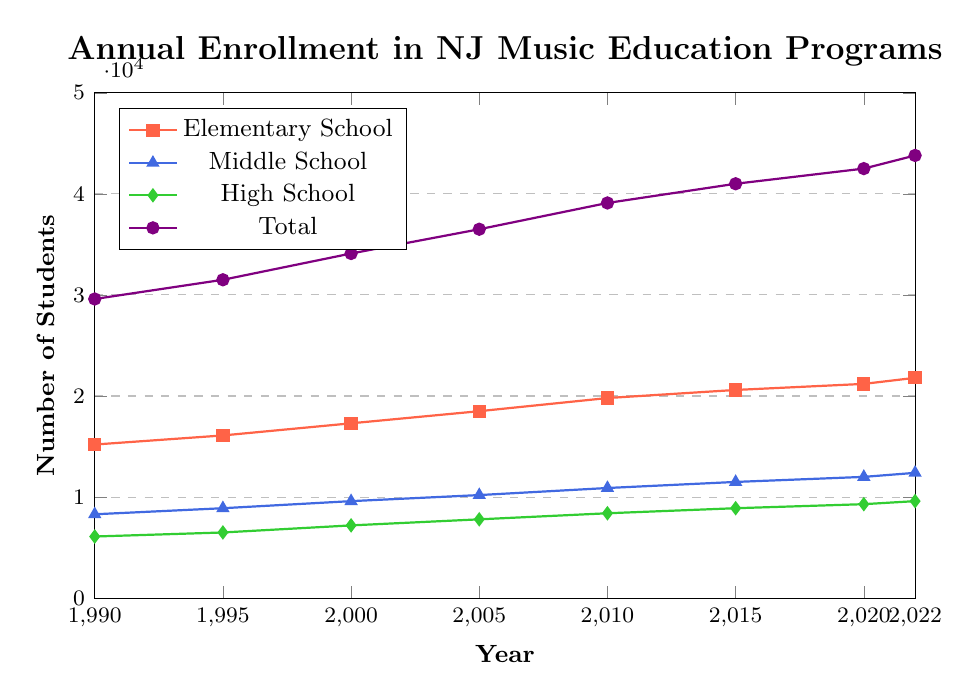What's the total enrollment for music education programs in 2005? Look for the data point in the "Total" series for the year 2005, which shows the total number of students enrolled in that year.
Answer: 36500 How many more students were enrolled in elementary school music programs in 2022 compared to 1990? Subtract the number of students enrolled in elementary schools in 1990 from the number enrolled in 2022 (21800 - 15200).
Answer: 6600 Which school level had the highest increase in student enrollment from 1990 to 2022? Calculate the difference in student enrollment for each school level between 1990 and 2022. Elementary: 21800 - 15200 = 6600, Middle: 12400 - 8300 = 4100, High: 9600 - 6100 = 3500. Identify the highest difference.
Answer: Elementary School What is the average annual enrollment in middle school music programs from 1990 to 2022? Sum the middle school enrollments across all years and divide by the number of data points (8300 + 8900 + 9600 + 10200 + 10900 + 11500 + 12000 + 12400) / 8.
Answer: 10350 By how much did the total number of students enrolled in music programs increase from 2000 to 2020? Subtract the total enrollment in 2000 from the total enrollment in 2020 (42500 - 34100).
Answer: 8400 In which year did high school music enrollment first exceed 9000 students? Identify the first year in the "High School" series where the enrollment exceeds 9000. 2015: 8900, 2020: 9300.
Answer: 2020 Which school level had the least change in enrollment from 1990 to 2022? Calculate the difference in student enrollment for each school level between 1990 and 2022: Elementary: 6600, Middle: 4100, High: 3500. Identify the smallest difference.
Answer: High School What is the most noticeable trend in the total enrollment from 1990 to 2022? Observe the "Total" line; it shows a consistent upward trend from 1990 to 2022.
Answer: Consistent Increase Compare the enrollment growth rate between elementary school and middle school from 2010 to 2022. Calculate the growth rate for both groups from 2010 to 2022. Elementary: (21800 - 19800) / 19800 ≈ 0.101, Middle: (12400 - 10900) / 10900 ≈ 0.138.
Answer: Middle School has a higher growth rate How did the total enrollment change between 1995 and 2000? Subtract the total enrollment in 1995 from the total enrollment in 2000 (34100 - 31500).
Answer: 2600 